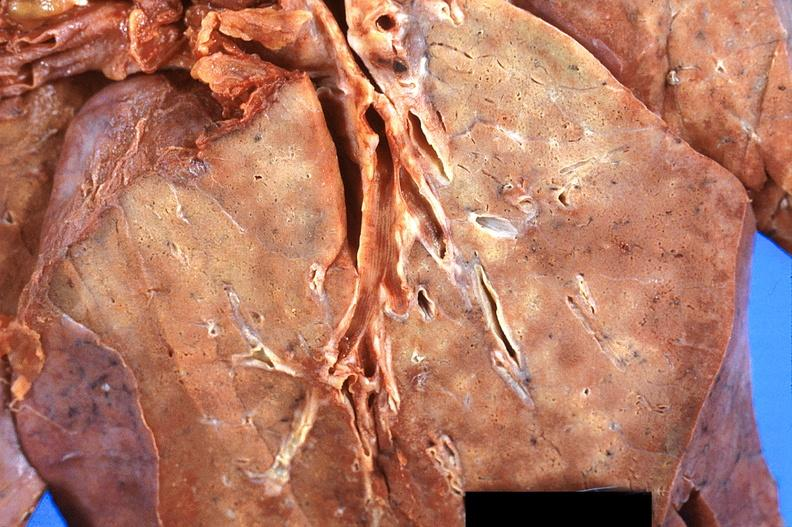s respiratory present?
Answer the question using a single word or phrase. Yes 